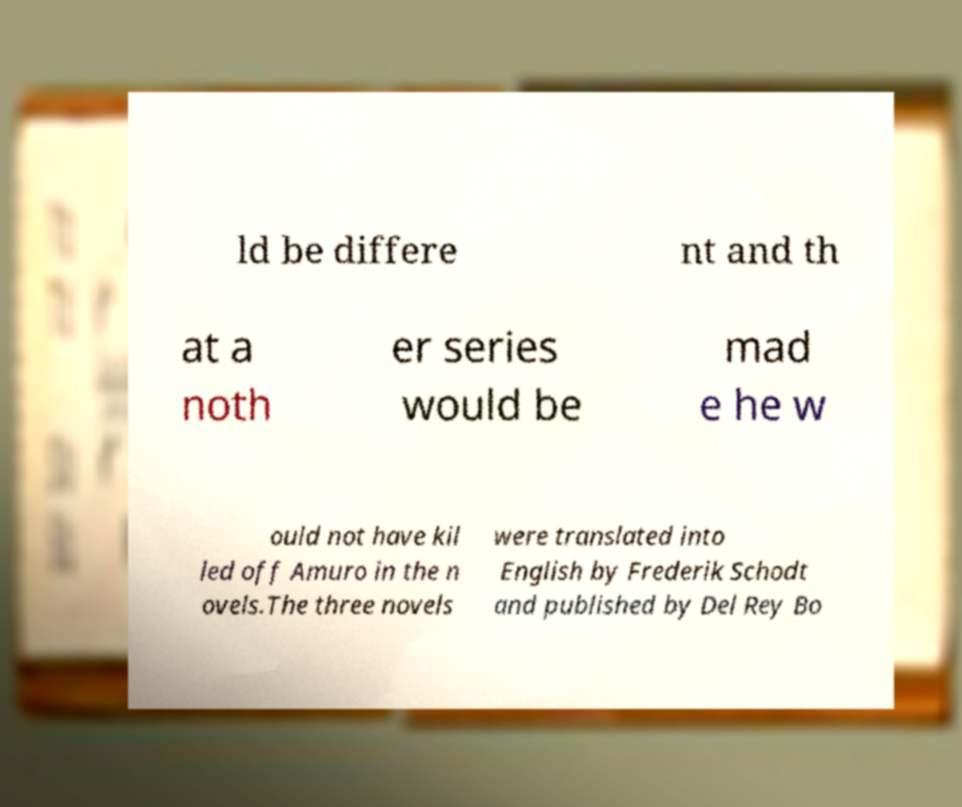There's text embedded in this image that I need extracted. Can you transcribe it verbatim? ld be differe nt and th at a noth er series would be mad e he w ould not have kil led off Amuro in the n ovels.The three novels were translated into English by Frederik Schodt and published by Del Rey Bo 